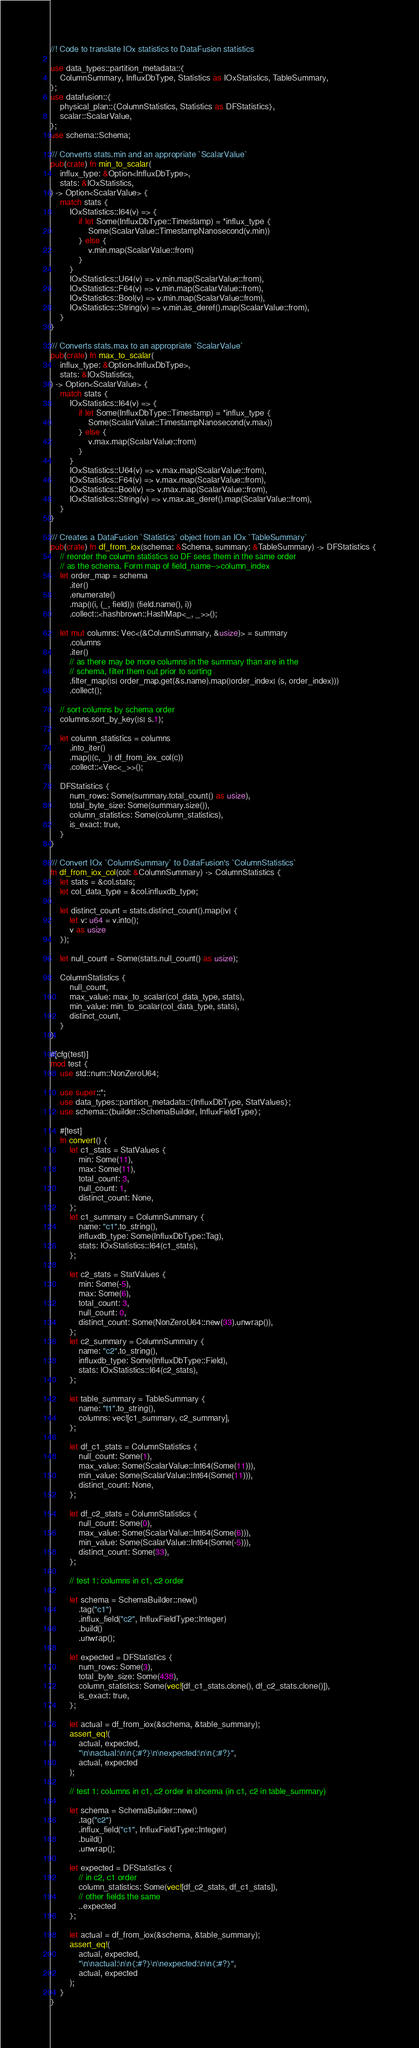<code> <loc_0><loc_0><loc_500><loc_500><_Rust_>//! Code to translate IOx statistics to DataFusion statistics

use data_types::partition_metadata::{
    ColumnSummary, InfluxDbType, Statistics as IOxStatistics, TableSummary,
};
use datafusion::{
    physical_plan::{ColumnStatistics, Statistics as DFStatistics},
    scalar::ScalarValue,
};
use schema::Schema;

/// Converts stats.min and an appropriate `ScalarValue`
pub(crate) fn min_to_scalar(
    influx_type: &Option<InfluxDbType>,
    stats: &IOxStatistics,
) -> Option<ScalarValue> {
    match stats {
        IOxStatistics::I64(v) => {
            if let Some(InfluxDbType::Timestamp) = *influx_type {
                Some(ScalarValue::TimestampNanosecond(v.min))
            } else {
                v.min.map(ScalarValue::from)
            }
        }
        IOxStatistics::U64(v) => v.min.map(ScalarValue::from),
        IOxStatistics::F64(v) => v.min.map(ScalarValue::from),
        IOxStatistics::Bool(v) => v.min.map(ScalarValue::from),
        IOxStatistics::String(v) => v.min.as_deref().map(ScalarValue::from),
    }
}

/// Converts stats.max to an appropriate `ScalarValue`
pub(crate) fn max_to_scalar(
    influx_type: &Option<InfluxDbType>,
    stats: &IOxStatistics,
) -> Option<ScalarValue> {
    match stats {
        IOxStatistics::I64(v) => {
            if let Some(InfluxDbType::Timestamp) = *influx_type {
                Some(ScalarValue::TimestampNanosecond(v.max))
            } else {
                v.max.map(ScalarValue::from)
            }
        }
        IOxStatistics::U64(v) => v.max.map(ScalarValue::from),
        IOxStatistics::F64(v) => v.max.map(ScalarValue::from),
        IOxStatistics::Bool(v) => v.max.map(ScalarValue::from),
        IOxStatistics::String(v) => v.max.as_deref().map(ScalarValue::from),
    }
}

/// Creates a DataFusion `Statistics` object from an IOx `TableSummary`
pub(crate) fn df_from_iox(schema: &Schema, summary: &TableSummary) -> DFStatistics {
    // reorder the column statistics so DF sees them in the same order
    // as the schema. Form map of field_name-->column_index
    let order_map = schema
        .iter()
        .enumerate()
        .map(|(i, (_, field))| (field.name(), i))
        .collect::<hashbrown::HashMap<_, _>>();

    let mut columns: Vec<(&ColumnSummary, &usize)> = summary
        .columns
        .iter()
        // as there may be more columns in the summary than are in the
        // schema, filter them out prior to sorting
        .filter_map(|s| order_map.get(&s.name).map(|order_index| (s, order_index)))
        .collect();

    // sort columns by schema order
    columns.sort_by_key(|s| s.1);

    let column_statistics = columns
        .into_iter()
        .map(|(c, _)| df_from_iox_col(c))
        .collect::<Vec<_>>();

    DFStatistics {
        num_rows: Some(summary.total_count() as usize),
        total_byte_size: Some(summary.size()),
        column_statistics: Some(column_statistics),
        is_exact: true,
    }
}

/// Convert IOx `ColumnSummary` to DataFusion's `ColumnStatistics`
fn df_from_iox_col(col: &ColumnSummary) -> ColumnStatistics {
    let stats = &col.stats;
    let col_data_type = &col.influxdb_type;

    let distinct_count = stats.distinct_count().map(|v| {
        let v: u64 = v.into();
        v as usize
    });

    let null_count = Some(stats.null_count() as usize);

    ColumnStatistics {
        null_count,
        max_value: max_to_scalar(col_data_type, stats),
        min_value: min_to_scalar(col_data_type, stats),
        distinct_count,
    }
}

#[cfg(test)]
mod test {
    use std::num::NonZeroU64;

    use super::*;
    use data_types::partition_metadata::{InfluxDbType, StatValues};
    use schema::{builder::SchemaBuilder, InfluxFieldType};

    #[test]
    fn convert() {
        let c1_stats = StatValues {
            min: Some(11),
            max: Some(11),
            total_count: 3,
            null_count: 1,
            distinct_count: None,
        };
        let c1_summary = ColumnSummary {
            name: "c1".to_string(),
            influxdb_type: Some(InfluxDbType::Tag),
            stats: IOxStatistics::I64(c1_stats),
        };

        let c2_stats = StatValues {
            min: Some(-5),
            max: Some(6),
            total_count: 3,
            null_count: 0,
            distinct_count: Some(NonZeroU64::new(33).unwrap()),
        };
        let c2_summary = ColumnSummary {
            name: "c2".to_string(),
            influxdb_type: Some(InfluxDbType::Field),
            stats: IOxStatistics::I64(c2_stats),
        };

        let table_summary = TableSummary {
            name: "t1".to_string(),
            columns: vec![c1_summary, c2_summary],
        };

        let df_c1_stats = ColumnStatistics {
            null_count: Some(1),
            max_value: Some(ScalarValue::Int64(Some(11))),
            min_value: Some(ScalarValue::Int64(Some(11))),
            distinct_count: None,
        };

        let df_c2_stats = ColumnStatistics {
            null_count: Some(0),
            max_value: Some(ScalarValue::Int64(Some(6))),
            min_value: Some(ScalarValue::Int64(Some(-5))),
            distinct_count: Some(33),
        };

        // test 1: columns in c1, c2 order

        let schema = SchemaBuilder::new()
            .tag("c1")
            .influx_field("c2", InfluxFieldType::Integer)
            .build()
            .unwrap();

        let expected = DFStatistics {
            num_rows: Some(3),
            total_byte_size: Some(438),
            column_statistics: Some(vec![df_c1_stats.clone(), df_c2_stats.clone()]),
            is_exact: true,
        };

        let actual = df_from_iox(&schema, &table_summary);
        assert_eq!(
            actual, expected,
            "\n\nactual:\n\n{:#?}\n\nexpected:\n\n{:#?}",
            actual, expected
        );

        // test 1: columns in c1, c2 order in shcema (in c1, c2 in table_summary)

        let schema = SchemaBuilder::new()
            .tag("c2")
            .influx_field("c1", InfluxFieldType::Integer)
            .build()
            .unwrap();

        let expected = DFStatistics {
            // in c2, c1 order
            column_statistics: Some(vec![df_c2_stats, df_c1_stats]),
            // other fields the same
            ..expected
        };

        let actual = df_from_iox(&schema, &table_summary);
        assert_eq!(
            actual, expected,
            "\n\nactual:\n\n{:#?}\n\nexpected:\n\n{:#?}",
            actual, expected
        );
    }
}
</code> 